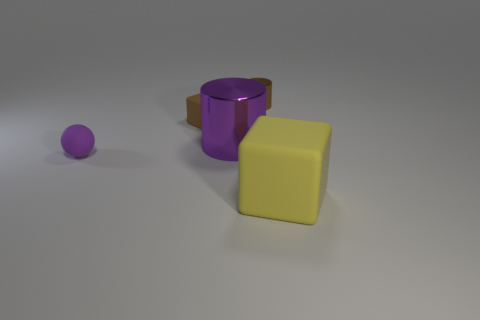What colors do the objects in the image have? The objects exhibit a variety of colors. The sphere is purple, the cylinder is a dark pink or magenta, the angled cuboid or rectangular prism is brown, and the cube is yellow. 